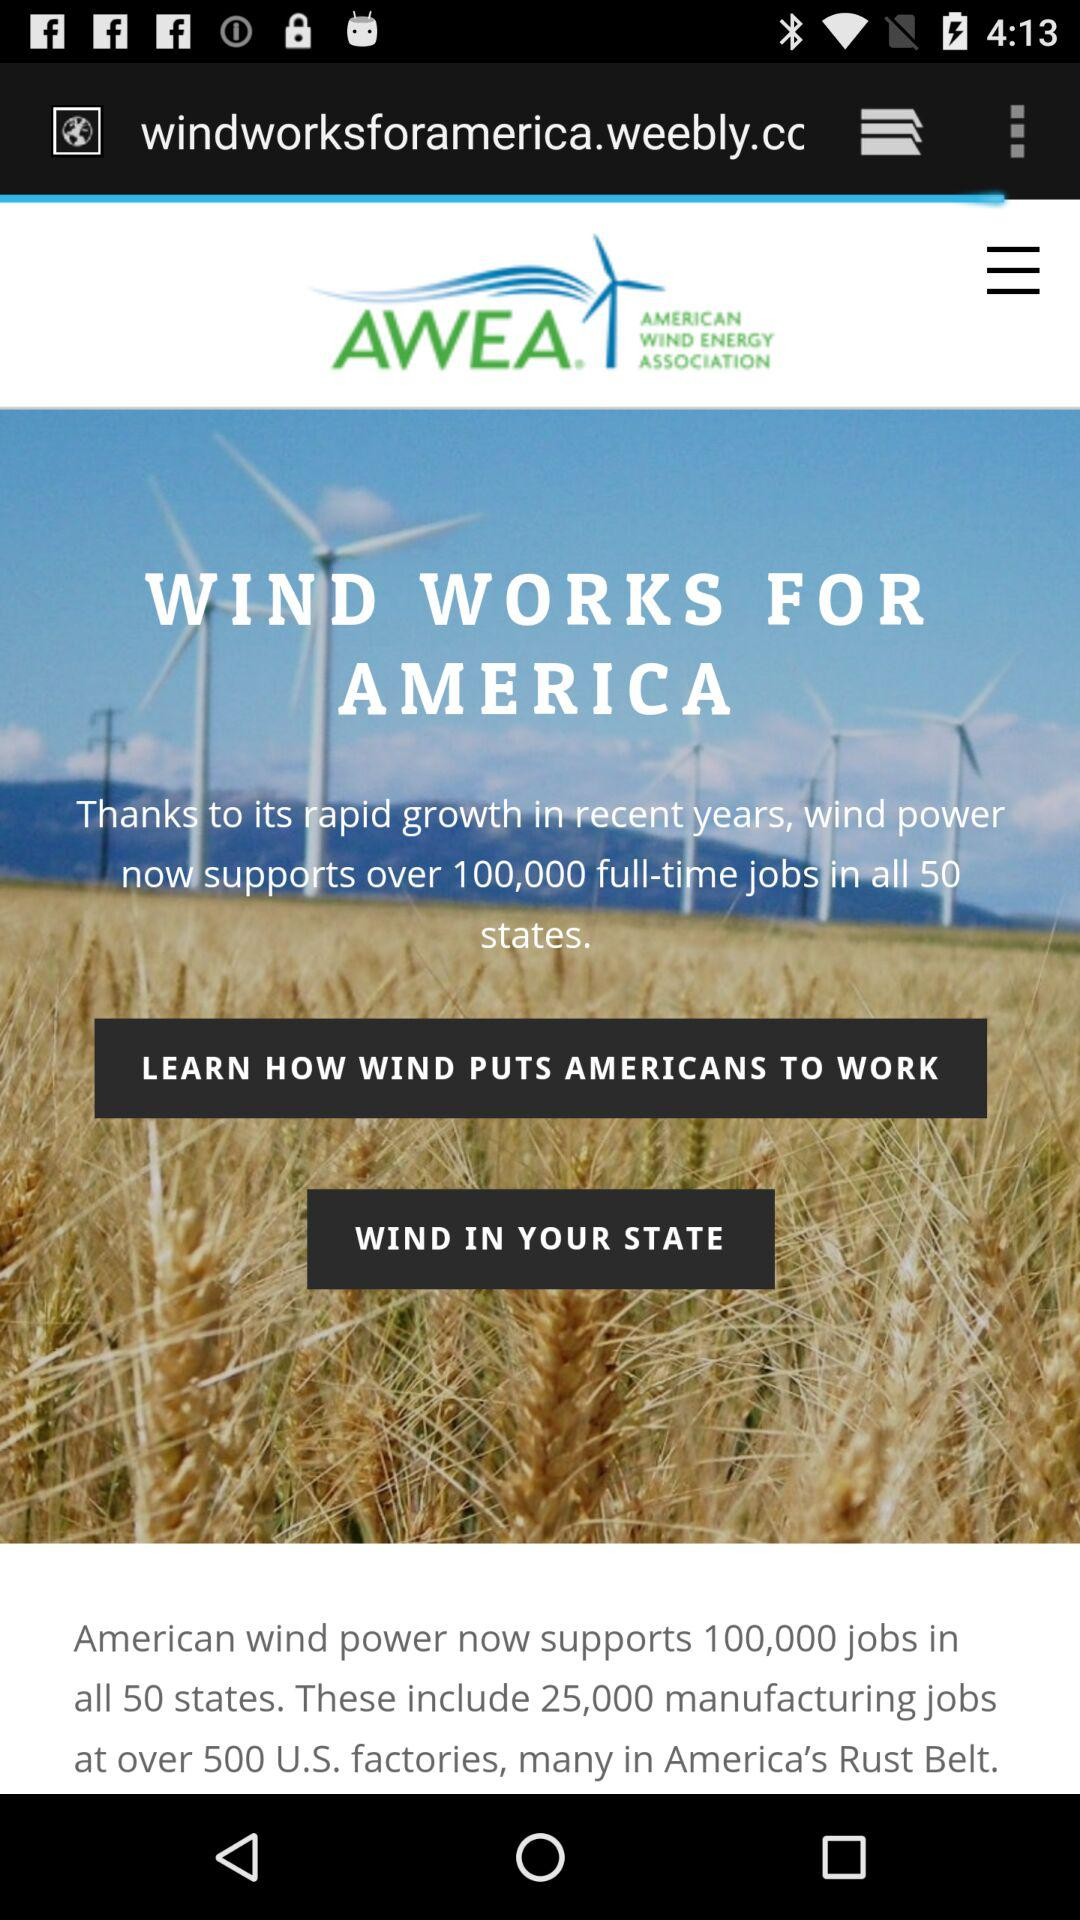How many states does American wind power support now? The American wind power supports 50 states. 